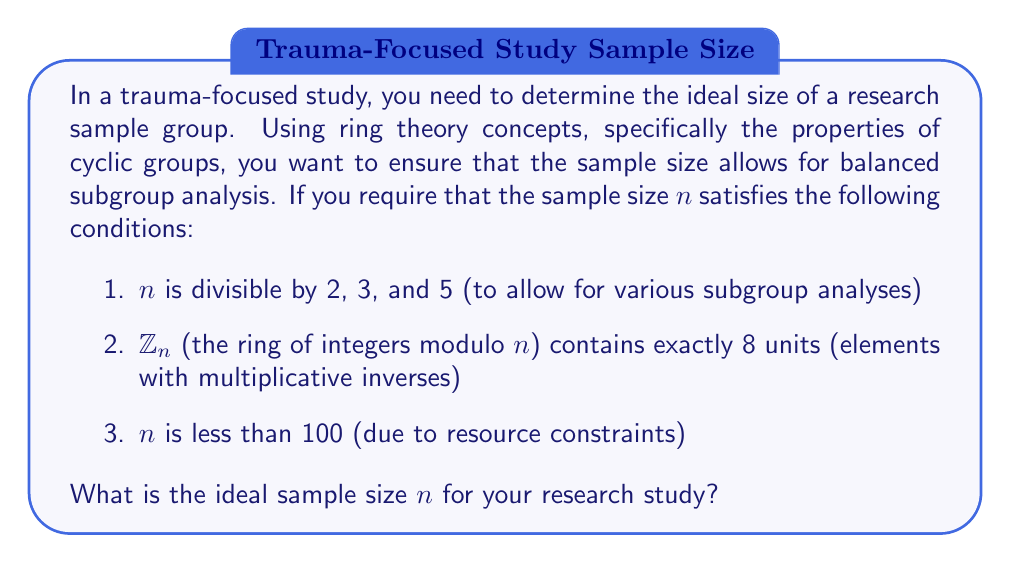Solve this math problem. To solve this problem, we'll use the following steps:

1. Find the smallest number divisible by 2, 3, and 5:
   $\text{lcm}(2,3,5) = 30$

2. The possible values for $n$ less than 100 that satisfy the first condition are:
   30, 60, 90

3. Now, we need to check which of these values satisfies the second condition. The number of units in $\mathbb{Z}_n$ is given by Euler's totient function $\phi(n)$.

4. For $\mathbb{Z}_n$ to have exactly 8 units, we need $\phi(n) = 8$.

5. Let's calculate $\phi(n)$ for each possible value:

   For $n = 30$:
   $\phi(30) = \phi(2 \cdot 3 \cdot 5) = \phi(2) \cdot \phi(3) \cdot \phi(5) = 1 \cdot 2 \cdot 4 = 8$

   For $n = 60$:
   $\phi(60) = \phi(2^2 \cdot 3 \cdot 5) = \phi(4) \cdot \phi(3) \cdot \phi(5) = 2 \cdot 2 \cdot 4 = 16$

   For $n = 90$:
   $\phi(90) = \phi(2 \cdot 3^2 \cdot 5) = \phi(2) \cdot \phi(9) \cdot \phi(5) = 1 \cdot 6 \cdot 4 = 24$

6. Only $n = 30$ satisfies all the conditions.

Therefore, the ideal sample size for the research study is 30.
Answer: The ideal sample size $n$ for the research study is 30. 